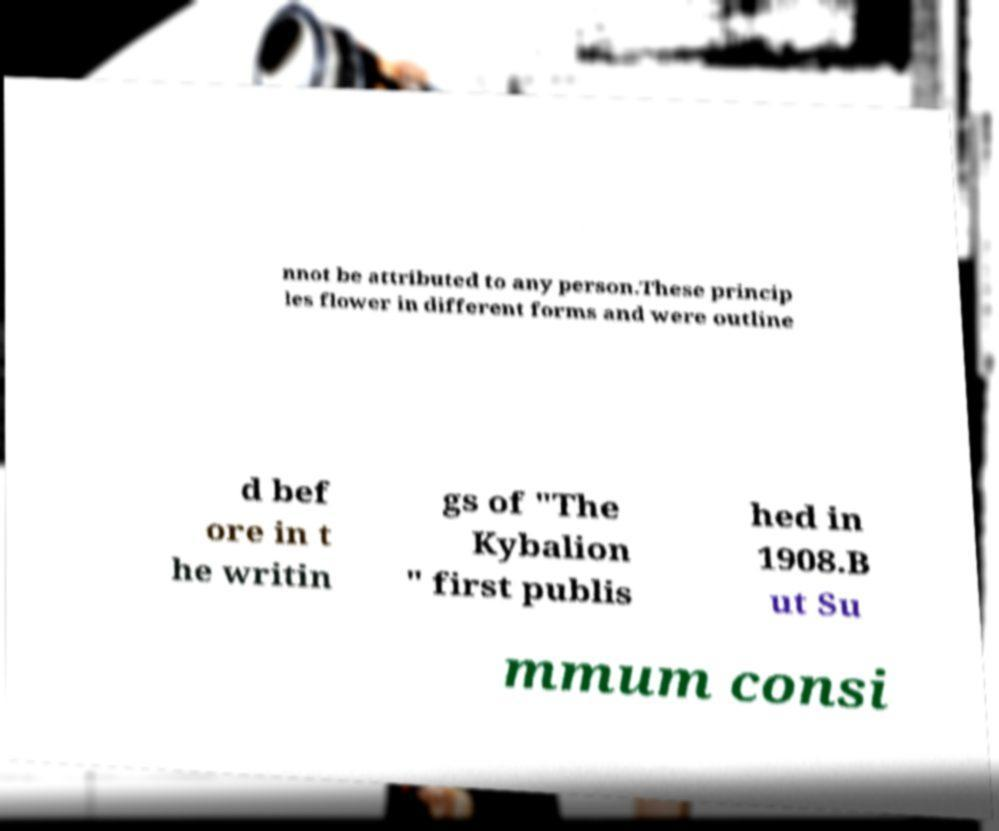Can you read and provide the text displayed in the image?This photo seems to have some interesting text. Can you extract and type it out for me? nnot be attributed to any person.These princip les flower in different forms and were outline d bef ore in t he writin gs of "The Kybalion " first publis hed in 1908.B ut Su mmum consi 